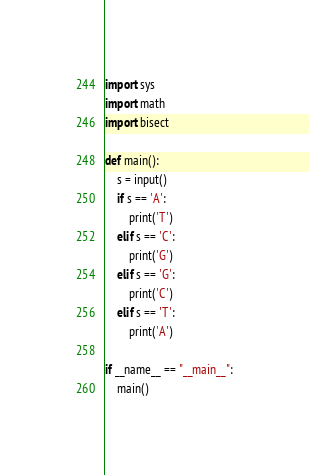<code> <loc_0><loc_0><loc_500><loc_500><_Python_>import sys
import math
import bisect

def main():
    s = input()
    if s == 'A':
        print('T')
    elif s == 'C':
        print('G')
    elif s == 'G':
        print('C')
    elif s == 'T':
        print('A')
    
if __name__ == "__main__":
    main()
</code> 